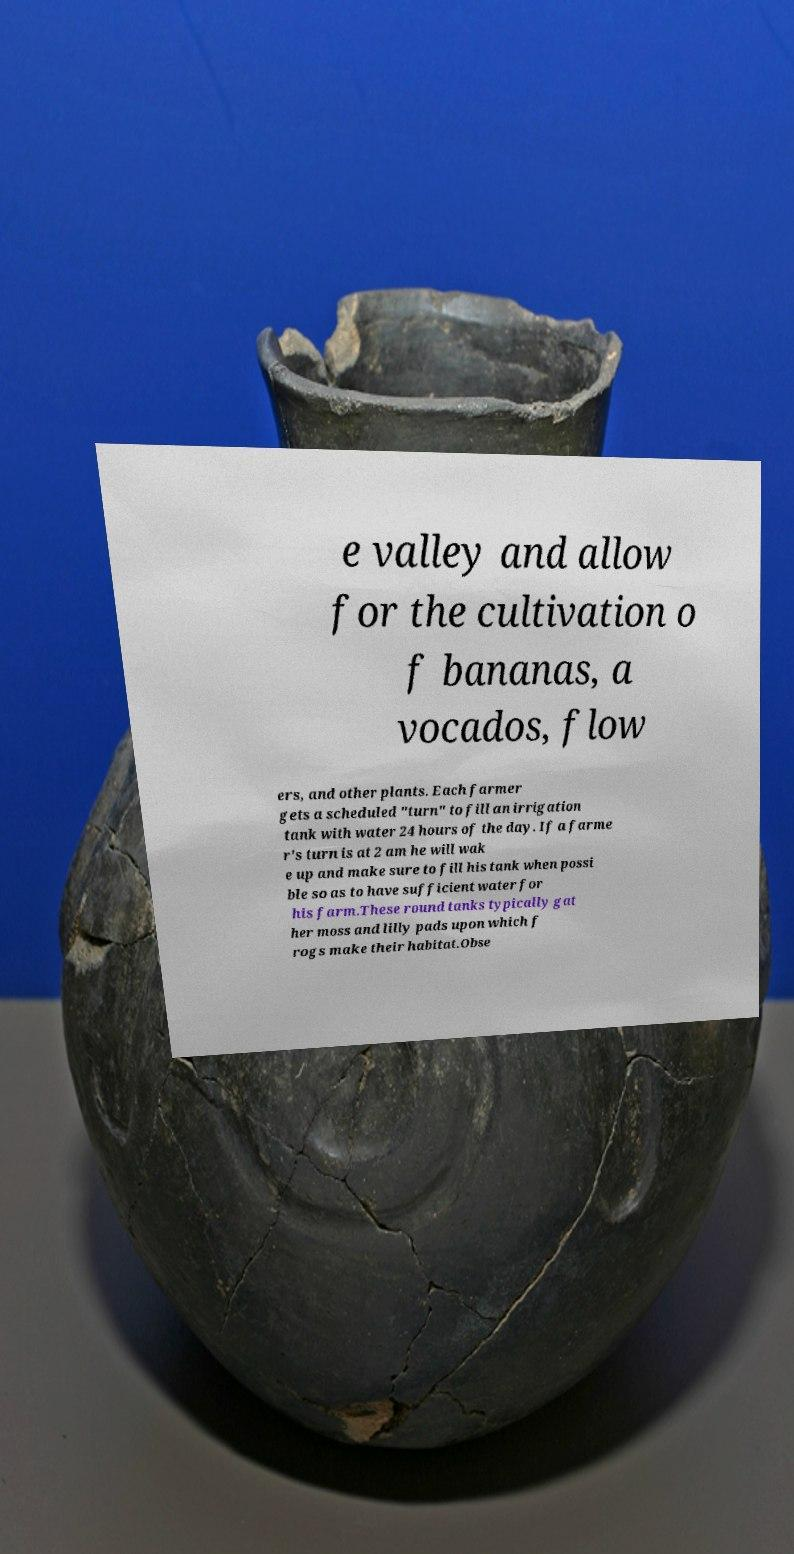Can you accurately transcribe the text from the provided image for me? e valley and allow for the cultivation o f bananas, a vocados, flow ers, and other plants. Each farmer gets a scheduled "turn" to fill an irrigation tank with water 24 hours of the day. If a farme r's turn is at 2 am he will wak e up and make sure to fill his tank when possi ble so as to have sufficient water for his farm.These round tanks typically gat her moss and lilly pads upon which f rogs make their habitat.Obse 